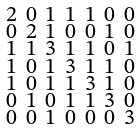Convert formula to latex. <formula><loc_0><loc_0><loc_500><loc_500>\begin{smallmatrix} 2 & 0 & 1 & 1 & 1 & 0 & 0 \\ 0 & 2 & 1 & 0 & 0 & 1 & 0 \\ 1 & 1 & 3 & 1 & 1 & 0 & 1 \\ 1 & 0 & 1 & 3 & 1 & 1 & 0 \\ 1 & 0 & 1 & 1 & 3 & 1 & 0 \\ 0 & 1 & 0 & 1 & 1 & 3 & 0 \\ 0 & 0 & 1 & 0 & 0 & 0 & 3 \end{smallmatrix}</formula> 